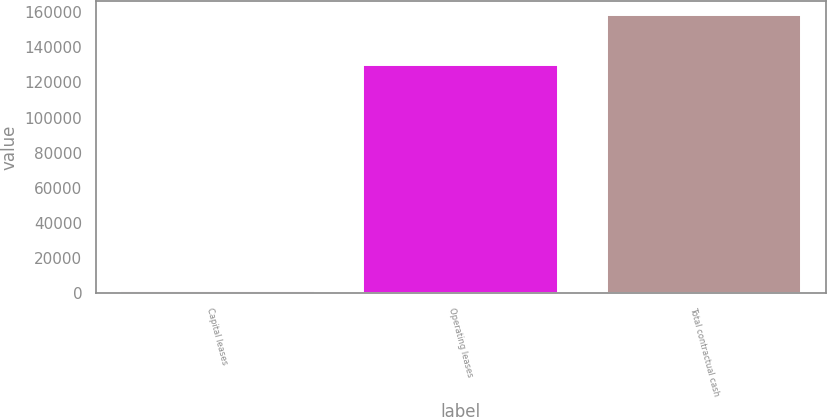Convert chart. <chart><loc_0><loc_0><loc_500><loc_500><bar_chart><fcel>Capital leases<fcel>Operating leases<fcel>Total contractual cash<nl><fcel>1296<fcel>129928<fcel>158474<nl></chart> 